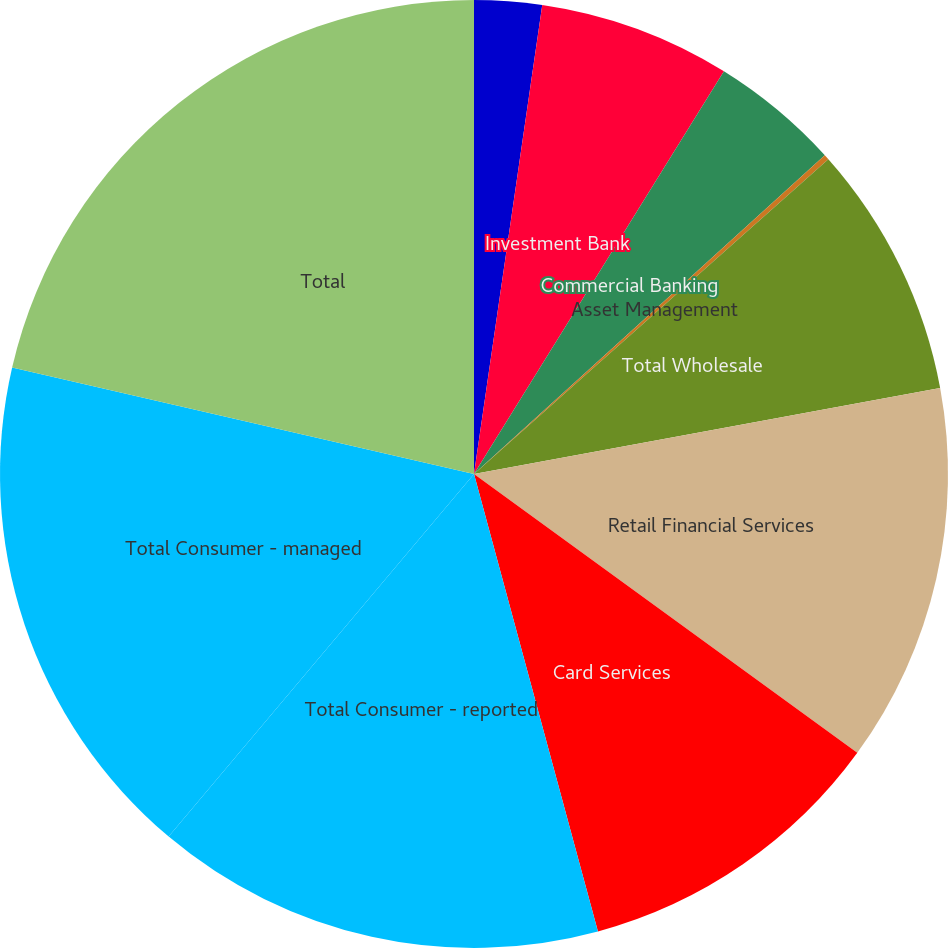Convert chart to OTSL. <chart><loc_0><loc_0><loc_500><loc_500><pie_chart><fcel>(in millions)<fcel>Investment Bank<fcel>Commercial Banking<fcel>Asset Management<fcel>Total Wholesale<fcel>Retail Financial Services<fcel>Card Services<fcel>Total Consumer - reported<fcel>Total Consumer - managed<fcel>Total<nl><fcel>2.3%<fcel>6.54%<fcel>4.42%<fcel>0.18%<fcel>8.66%<fcel>12.91%<fcel>10.78%<fcel>15.35%<fcel>17.47%<fcel>21.39%<nl></chart> 